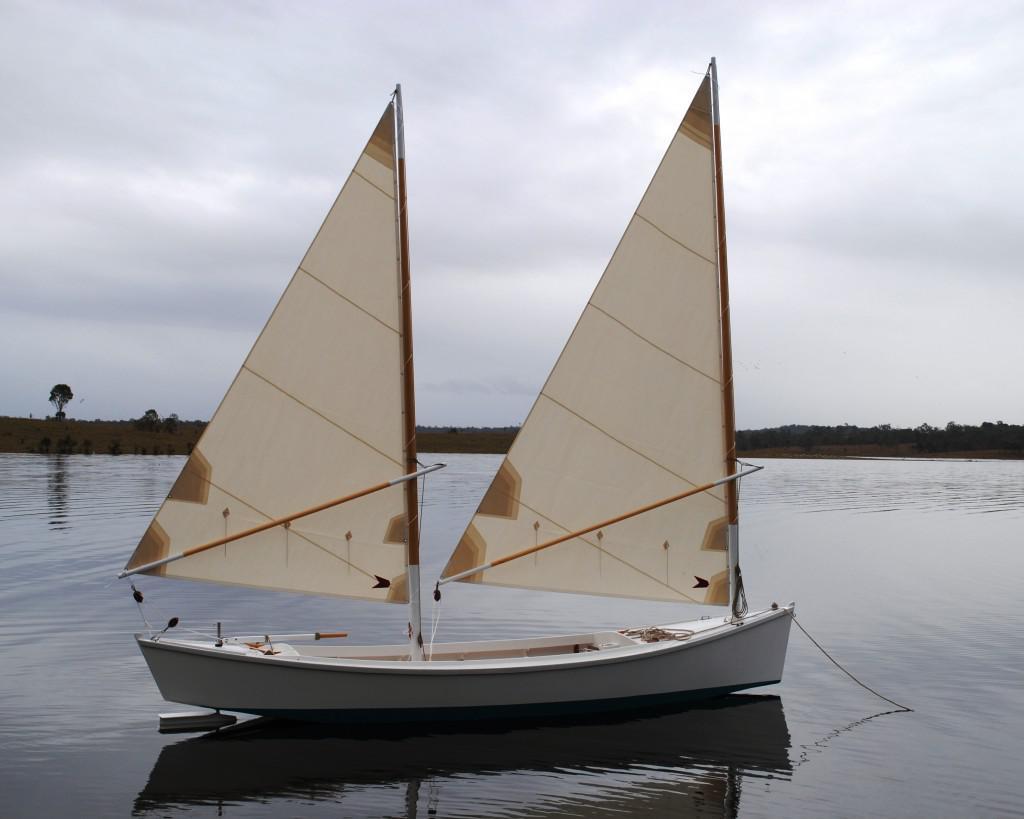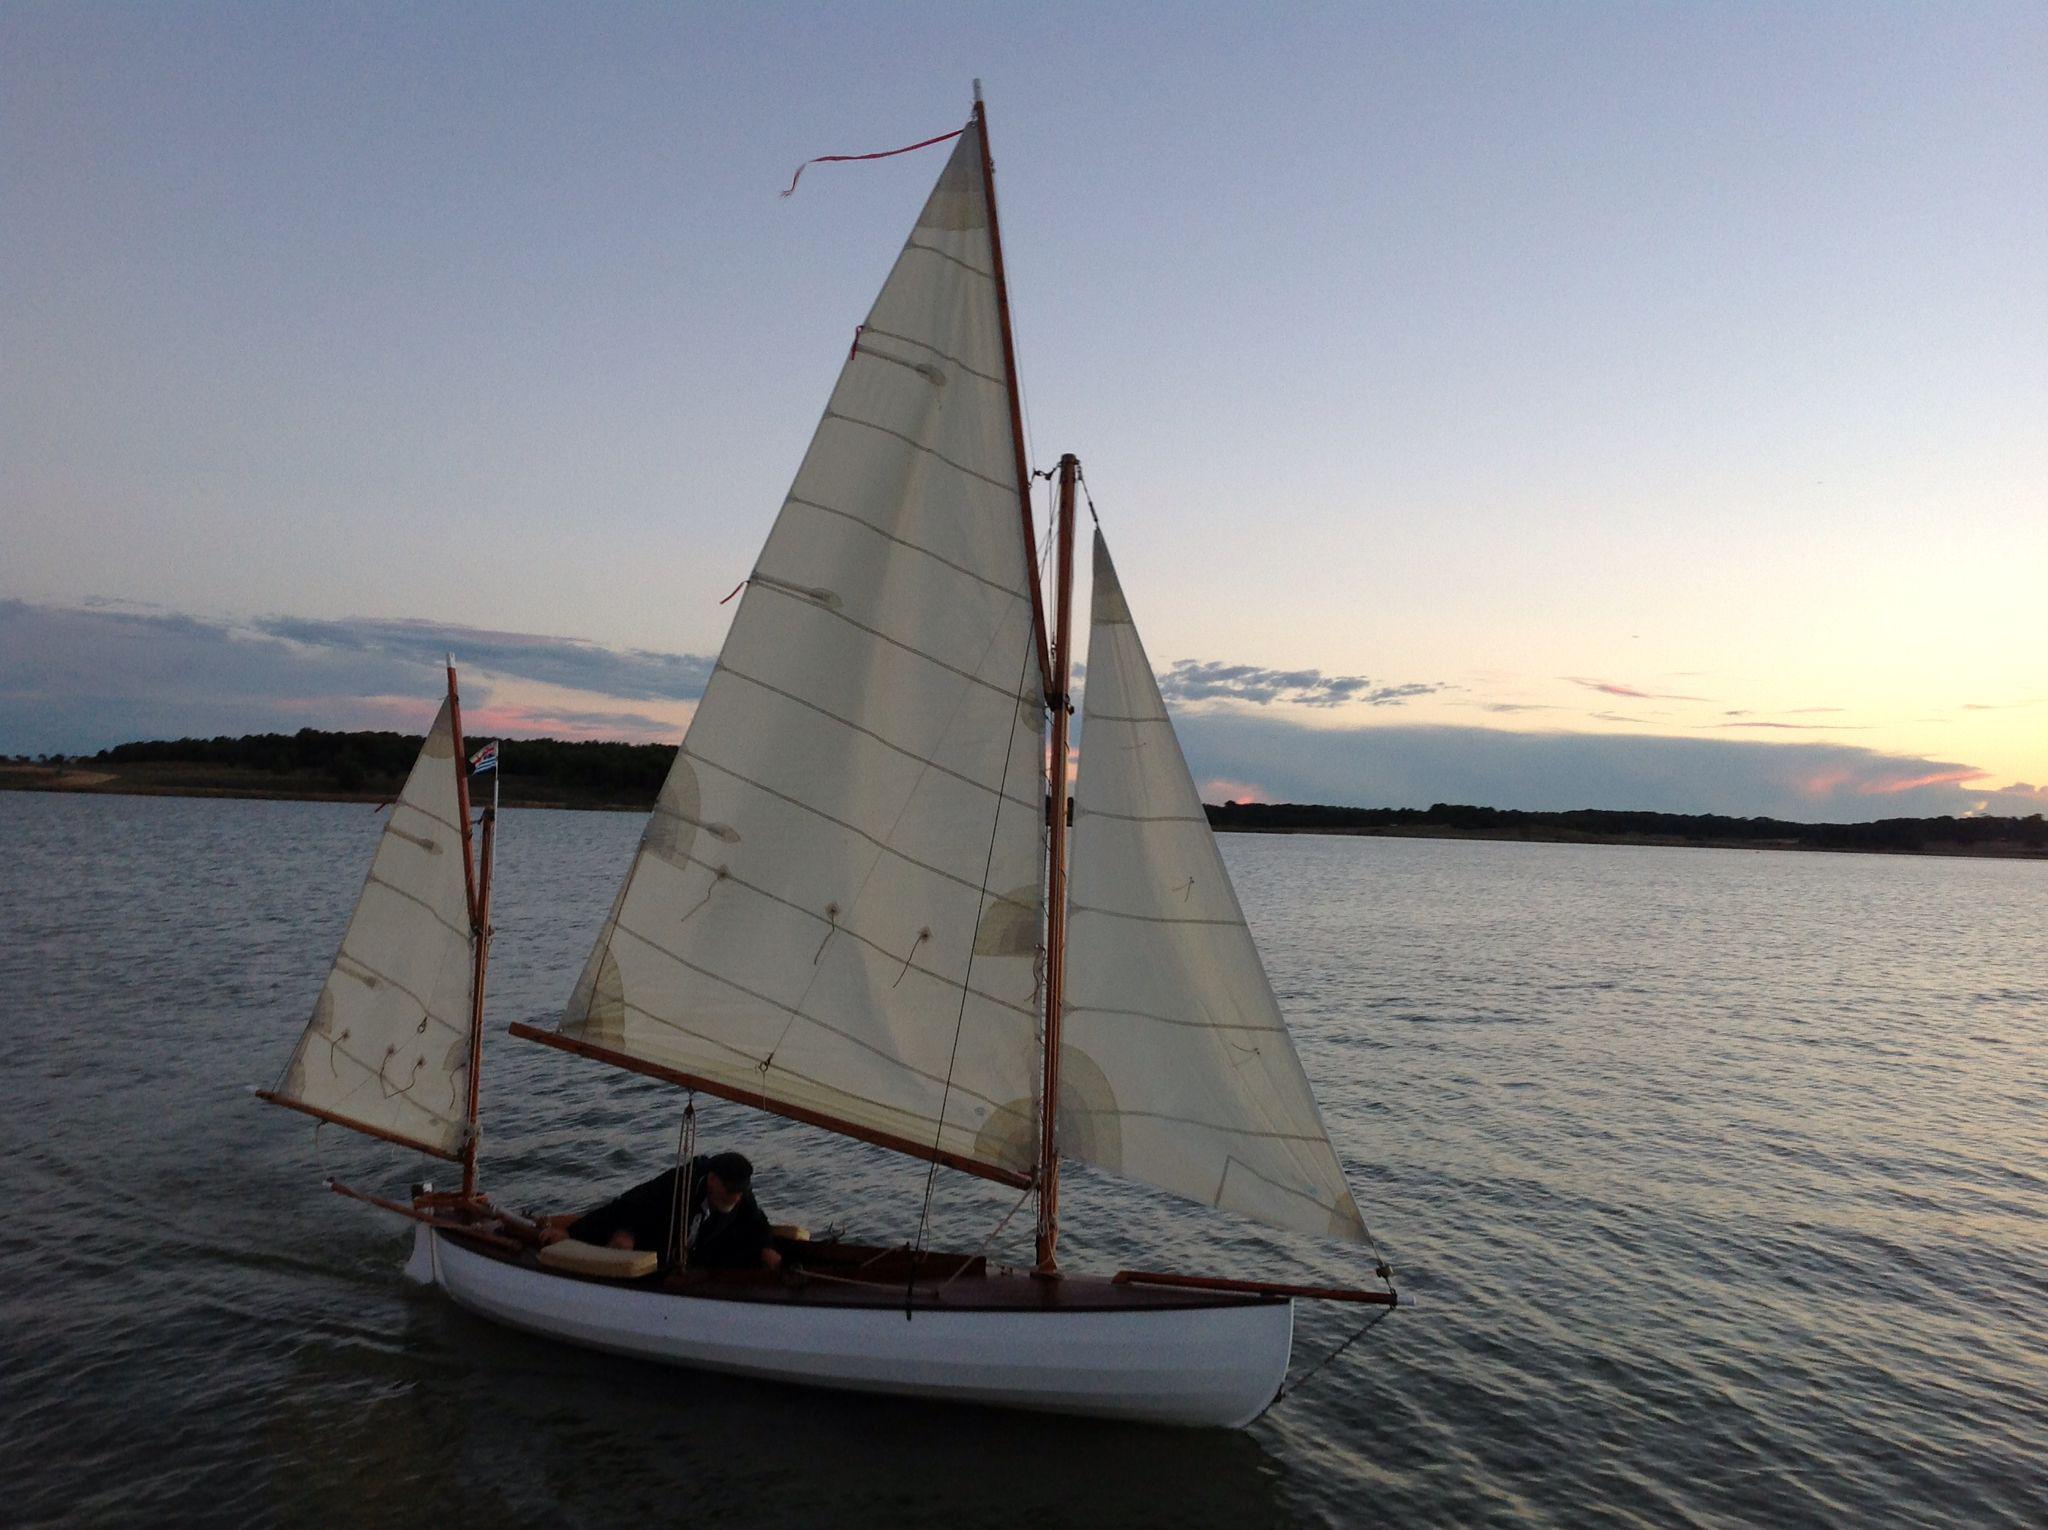The first image is the image on the left, the second image is the image on the right. For the images shown, is this caption "There are 5 raised sails in the image pair" true? Answer yes or no. Yes. The first image is the image on the left, the second image is the image on the right. Examine the images to the left and right. Is the description "There are exactly five sails." accurate? Answer yes or no. Yes. 